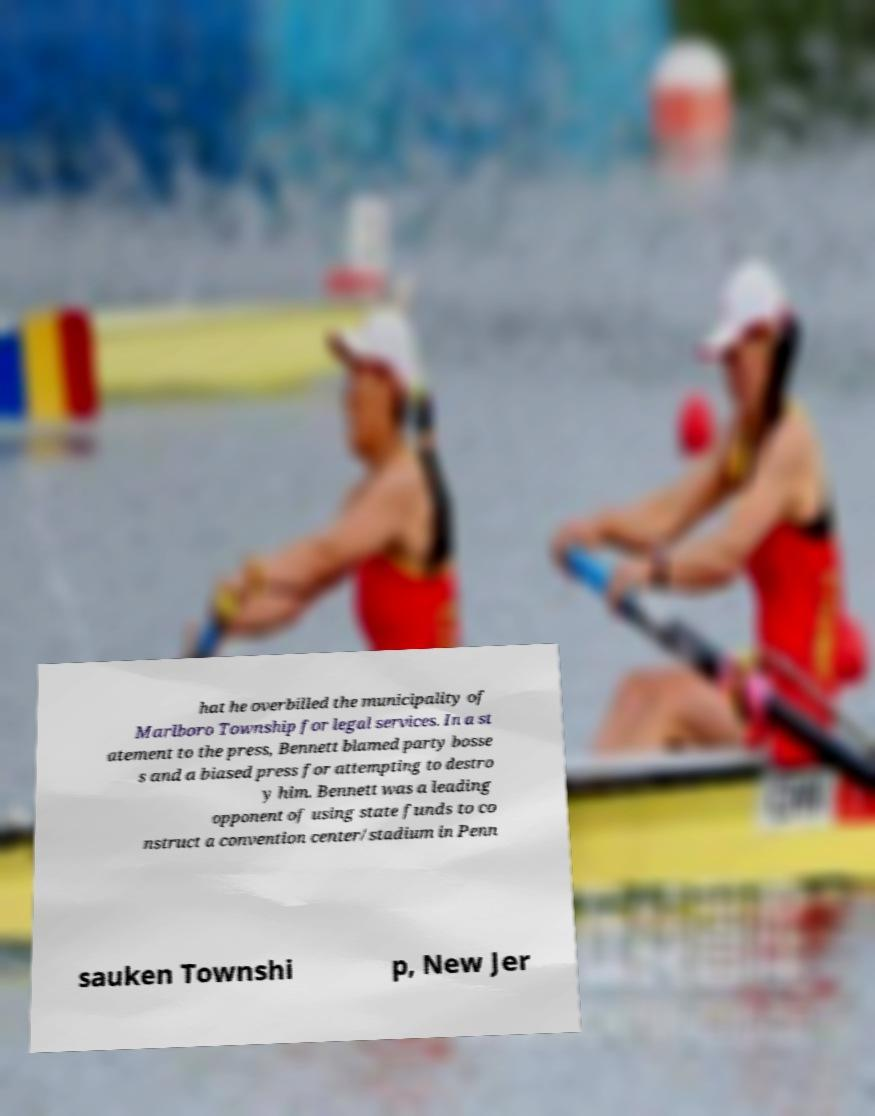Could you extract and type out the text from this image? hat he overbilled the municipality of Marlboro Township for legal services. In a st atement to the press, Bennett blamed party bosse s and a biased press for attempting to destro y him. Bennett was a leading opponent of using state funds to co nstruct a convention center/stadium in Penn sauken Townshi p, New Jer 